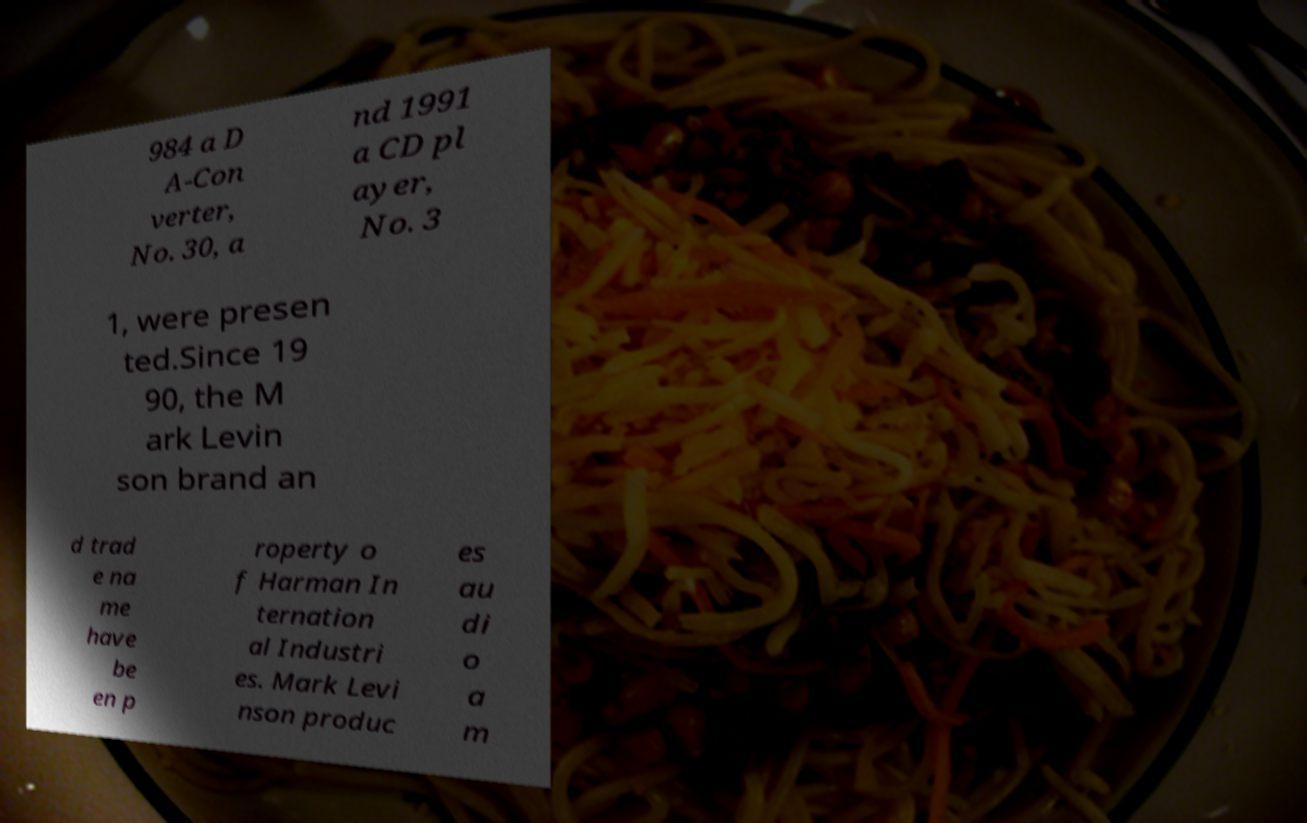Can you accurately transcribe the text from the provided image for me? 984 a D A-Con verter, No. 30, a nd 1991 a CD pl ayer, No. 3 1, were presen ted.Since 19 90, the M ark Levin son brand an d trad e na me have be en p roperty o f Harman In ternation al Industri es. Mark Levi nson produc es au di o a m 